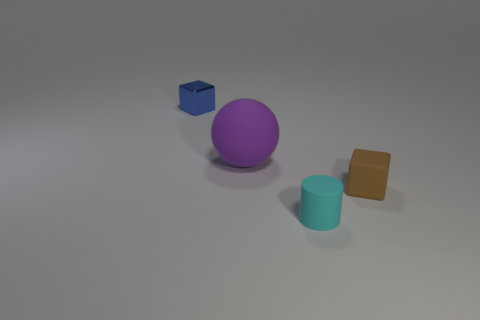Add 1 tiny brown rubber blocks. How many objects exist? 5 Subtract all cylinders. How many objects are left? 3 Subtract 0 yellow cubes. How many objects are left? 4 Subtract all tiny matte cylinders. Subtract all tiny red metal things. How many objects are left? 3 Add 1 blue blocks. How many blue blocks are left? 2 Add 4 cyan rubber cubes. How many cyan rubber cubes exist? 4 